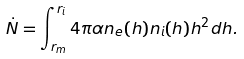<formula> <loc_0><loc_0><loc_500><loc_500>\dot { N } = \int _ { r _ { m } } ^ { r _ { i } } 4 \pi \alpha n _ { e } ( h ) n _ { i } ( h ) h ^ { 2 } d h .</formula> 